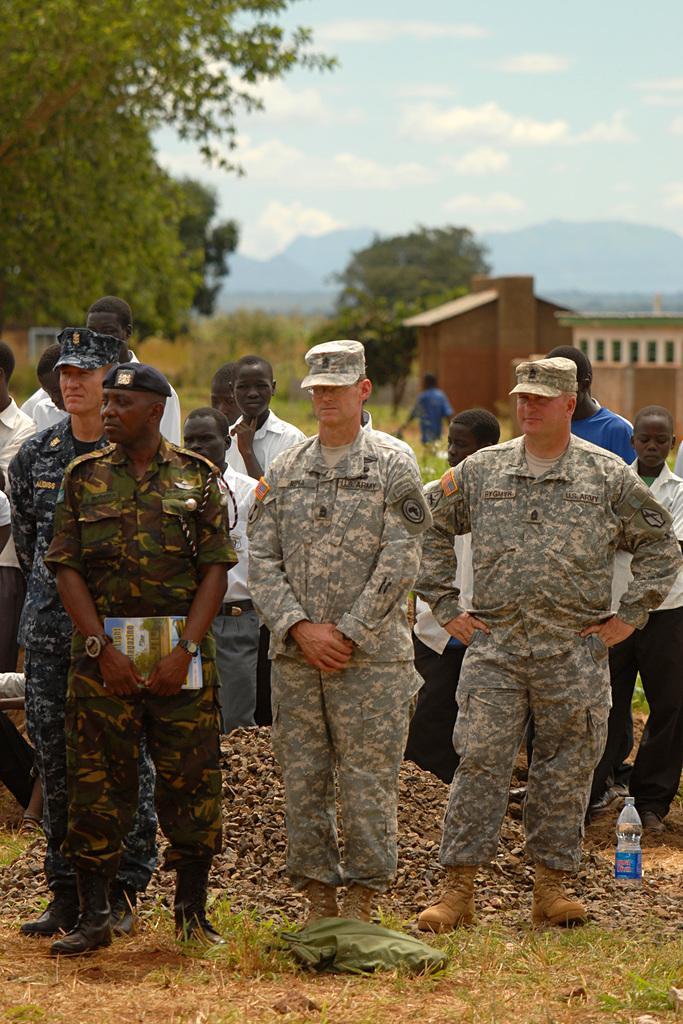Could you give a brief overview of what you see in this image? In this picture I can observe some men standing on the ground. Some of them are wearing caps on their heads. There is a water bottle on the right side. In the background I can observe building, trees and clouds in the sky. 